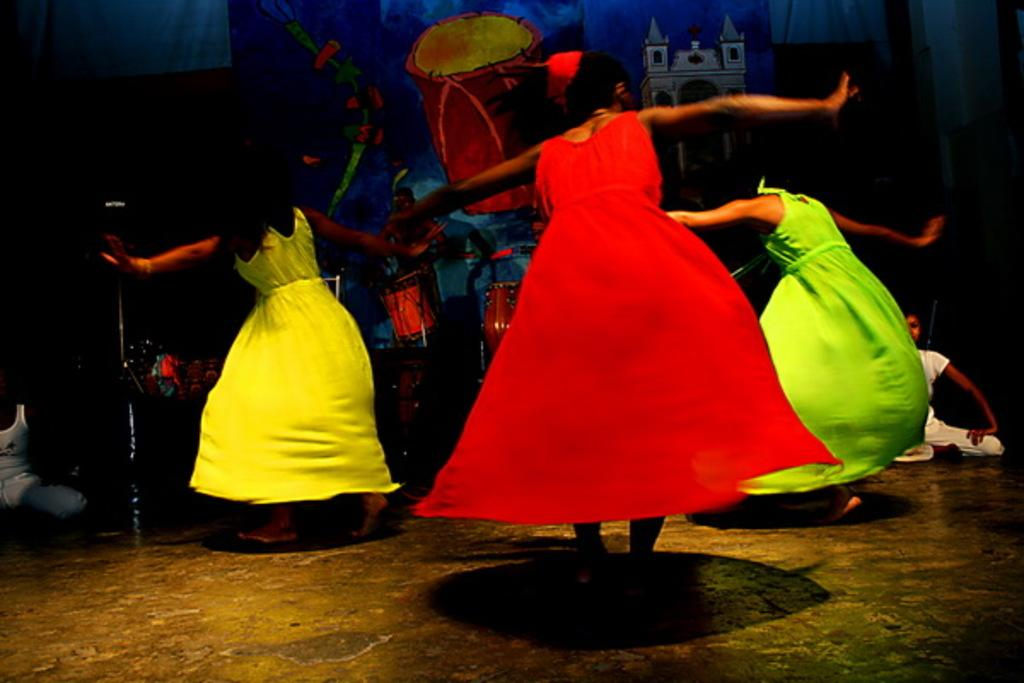How many women are in the image? There are three women in the image. What are the women wearing? The women are wearing frocks. What are the women doing in the image? The women are dancing. What can be seen in the background of the image? There are musical drums in the background. Can you describe the banner in the image? The banner has a musical drum and a building on it. How many people are in the image? There are two people in the image. What type of suit is the rose wearing in the image? There is no rose or suit present in the image. Is there a veil visible on any of the women in the image? No, there is no veil visible on any of the women in the image. 